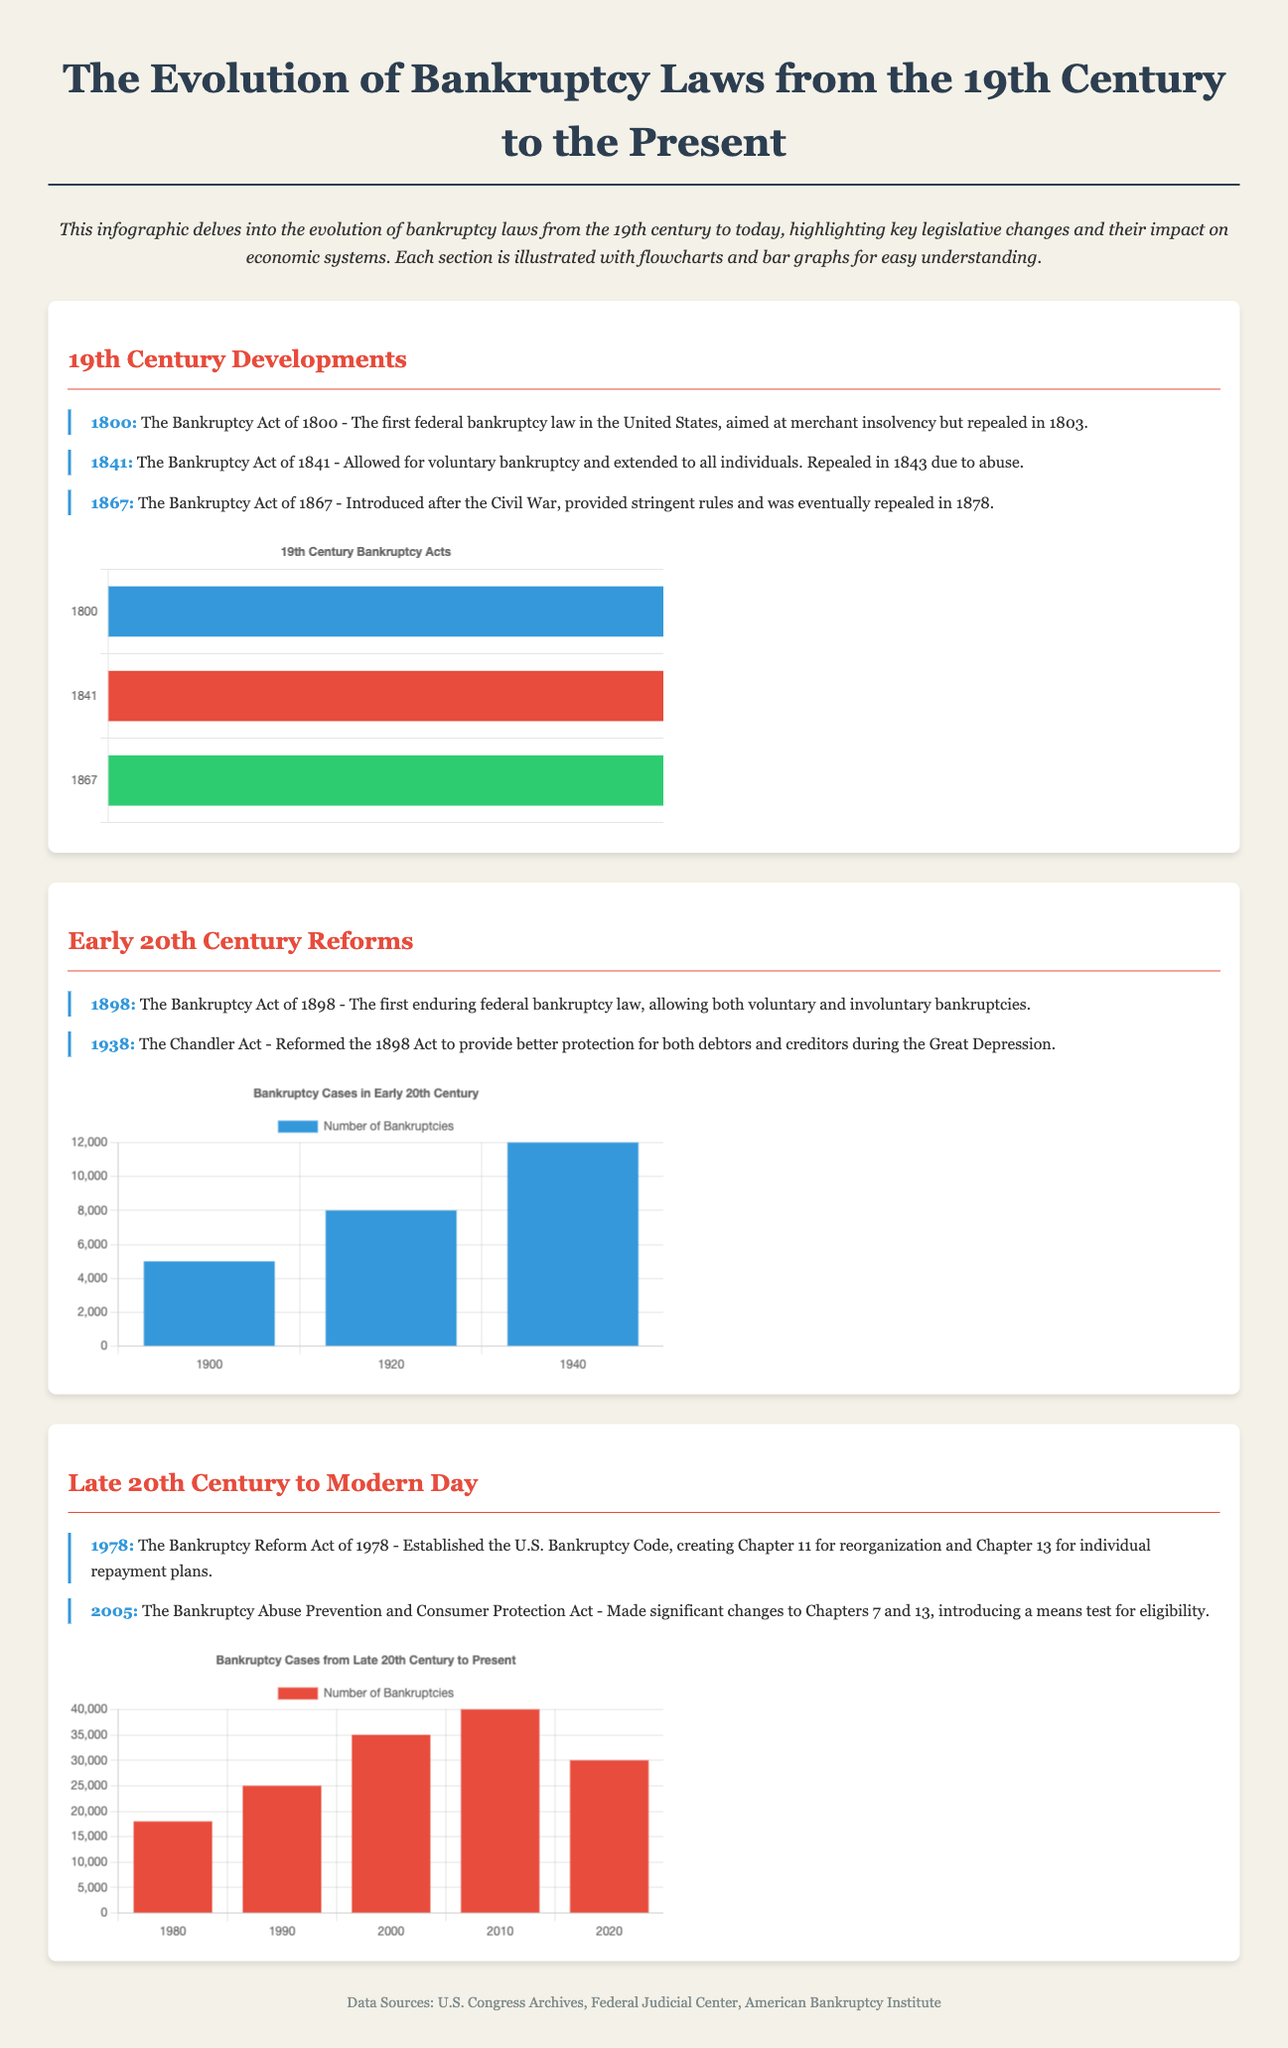What year was the first federal bankruptcy law enacted in the United States? The document states that the Bankruptcy Act of 1800 was the first federal bankruptcy law, introduced in the year 1800.
Answer: 1800 What was significant about the Bankruptcy Act of 1898? The document mentions that it was the first enduring federal bankruptcy law, allowing for both voluntary and involuntary bankruptcies.
Answer: Enduring federal bankruptcy law What legislation introduced Chapter 11 for reorganization? The document refers to the Bankruptcy Reform Act of 1978 as the legislation that established Chapter 11 for reorganization.
Answer: Bankruptcy Reform Act of 1978 How many bankruptcy acts were introduced in the 19th century? The document lists three acts that were introduced in the 19th century, which can be counted to answer this question.
Answer: Three What was the highest number of bankruptcies recorded in the bar graph for the years 1980 to 2020? The bar graph shows the number of bankruptcies peaked at 40000 in the year 2010.
Answer: 40000 What reform did the Chandler Act provide during the Great Depression? The document states that the Chandler Act reformed the 1898 Act to give better protection for both debtors and creditors.
Answer: Better protection for debtors and creditors Which act introduced a means test for eligibility? The document indicates that the Bankruptcy Abuse Prevention and Consumer Protection Act introduced a means test for eligibility.
Answer: Bankruptcy Abuse Prevention and Consumer Protection Act What color represents the number of bankruptcies in the early 20th century graph? The document specifies that the color blue is used in the bar graph for the number of bankruptcies in the early 20th century.
Answer: Blue 